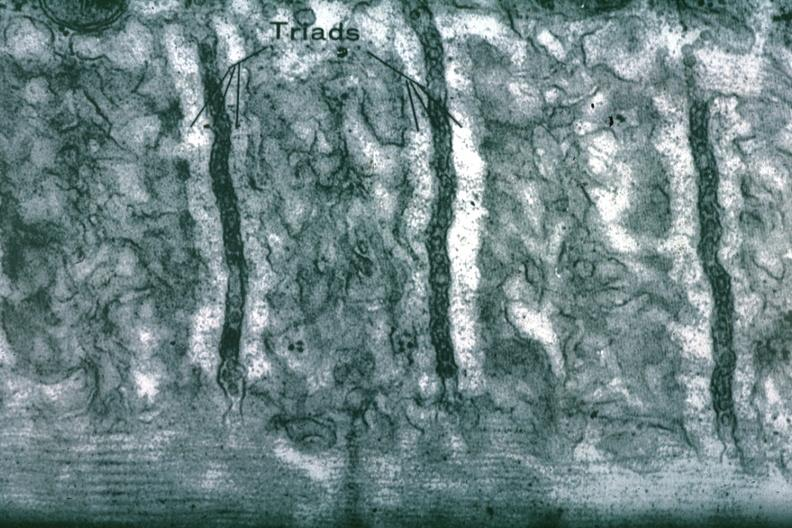what is present?
Answer the question using a single word or phrase. Myocardium 